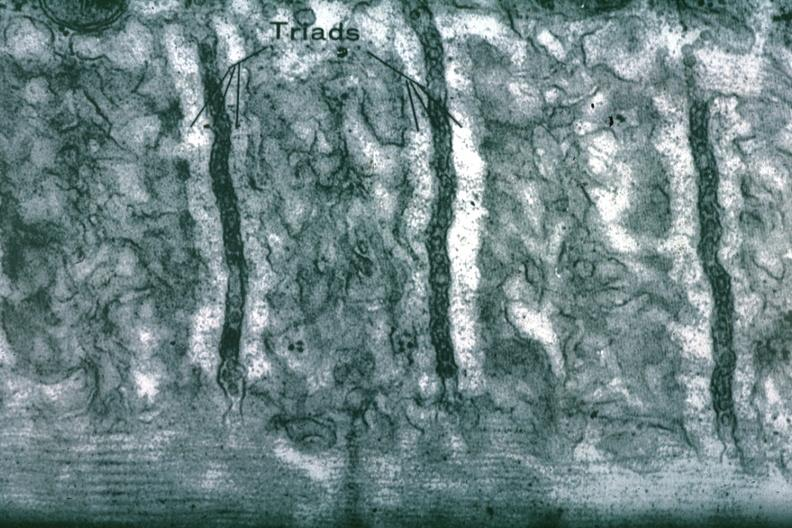what is present?
Answer the question using a single word or phrase. Myocardium 